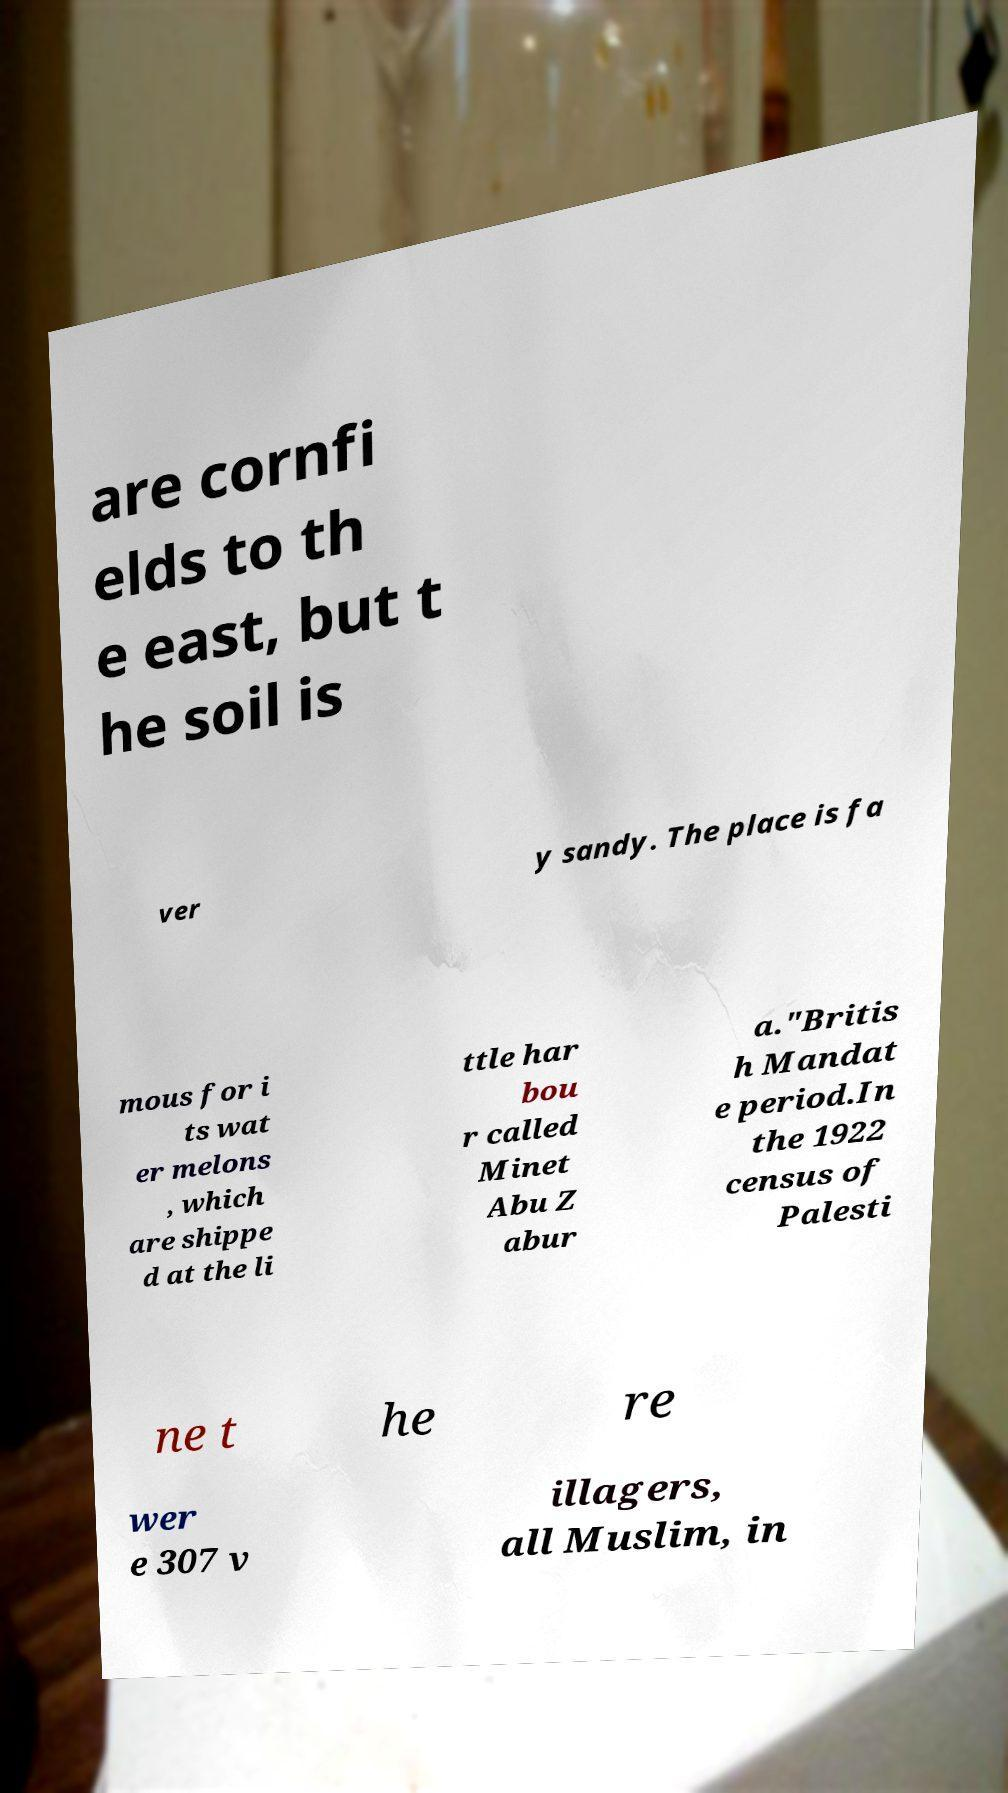I need the written content from this picture converted into text. Can you do that? are cornfi elds to th e east, but t he soil is ver y sandy. The place is fa mous for i ts wat er melons , which are shippe d at the li ttle har bou r called Minet Abu Z abur a."Britis h Mandat e period.In the 1922 census of Palesti ne t he re wer e 307 v illagers, all Muslim, in 